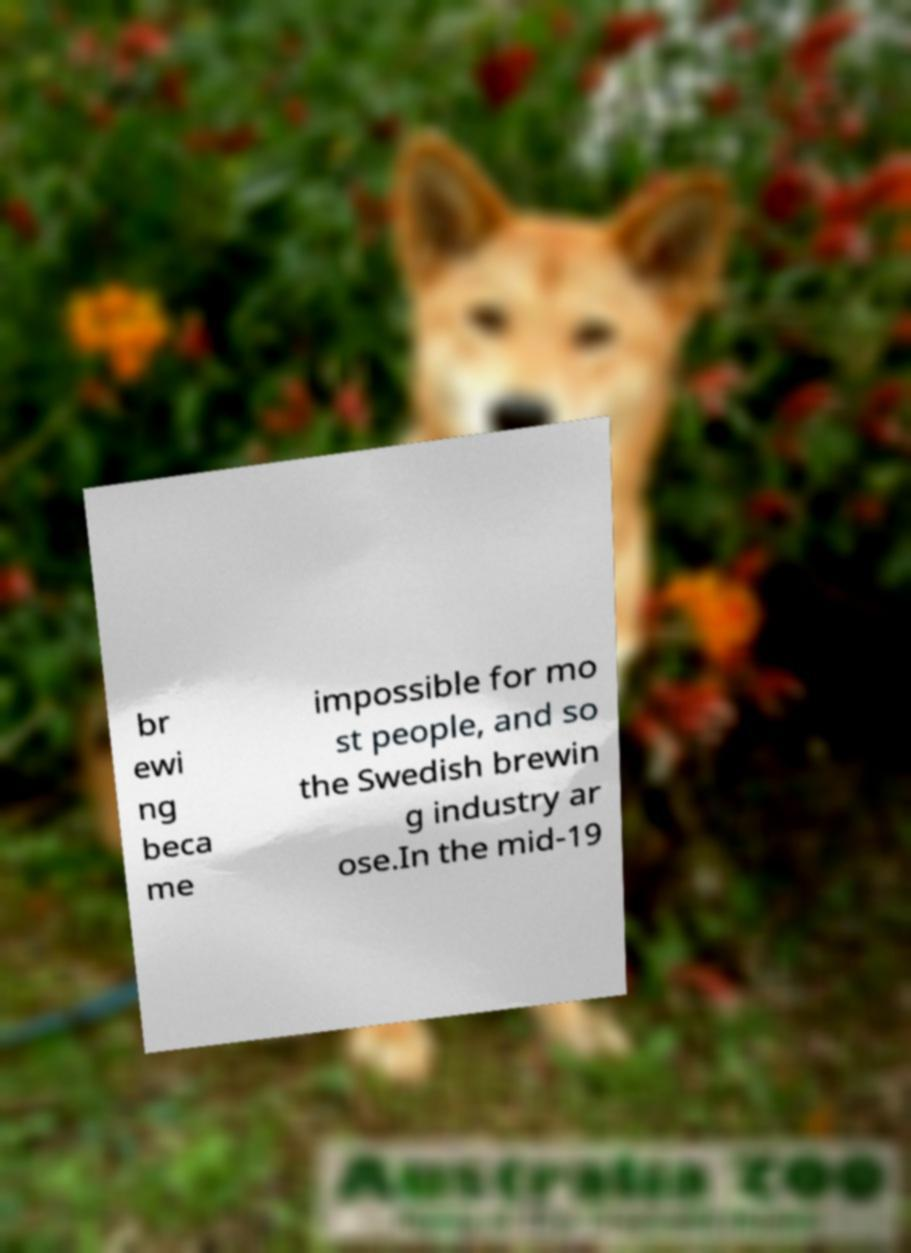What messages or text are displayed in this image? I need them in a readable, typed format. br ewi ng beca me impossible for mo st people, and so the Swedish brewin g industry ar ose.In the mid-19 